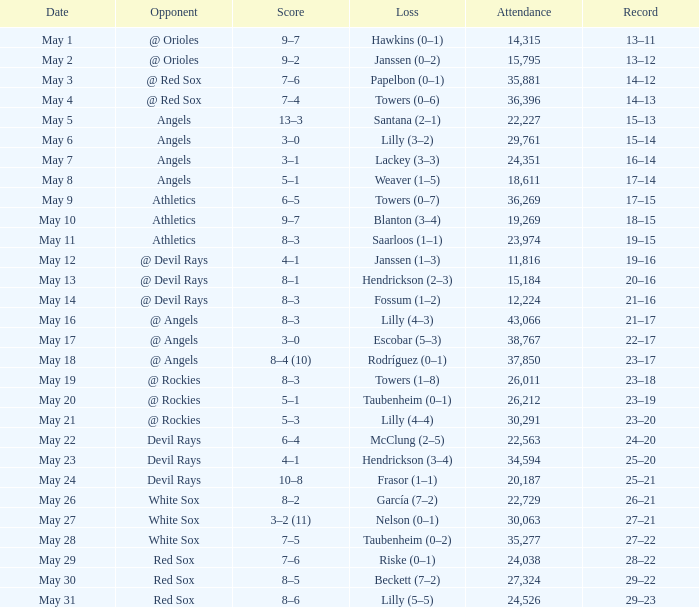When the team had their record of 16–14, what was the total attendance? 1.0. 